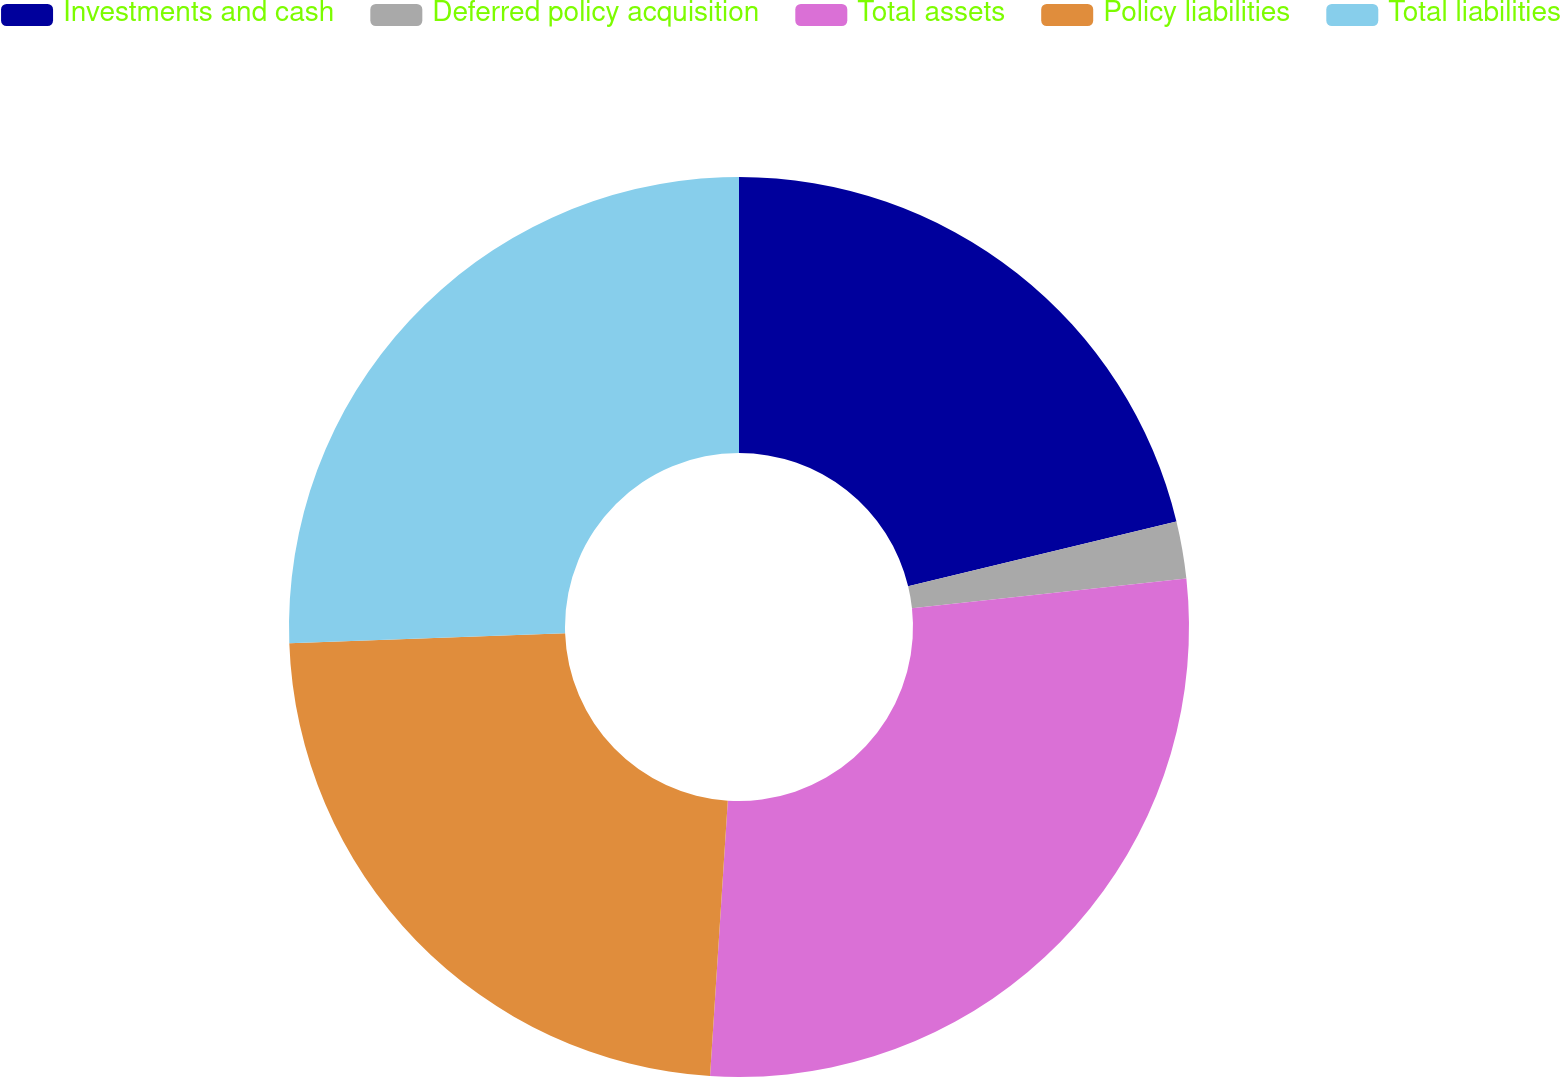Convert chart to OTSL. <chart><loc_0><loc_0><loc_500><loc_500><pie_chart><fcel>Investments and cash<fcel>Deferred policy acquisition<fcel>Total assets<fcel>Policy liabilities<fcel>Total liabilities<nl><fcel>21.23%<fcel>2.05%<fcel>27.74%<fcel>23.4%<fcel>25.57%<nl></chart> 